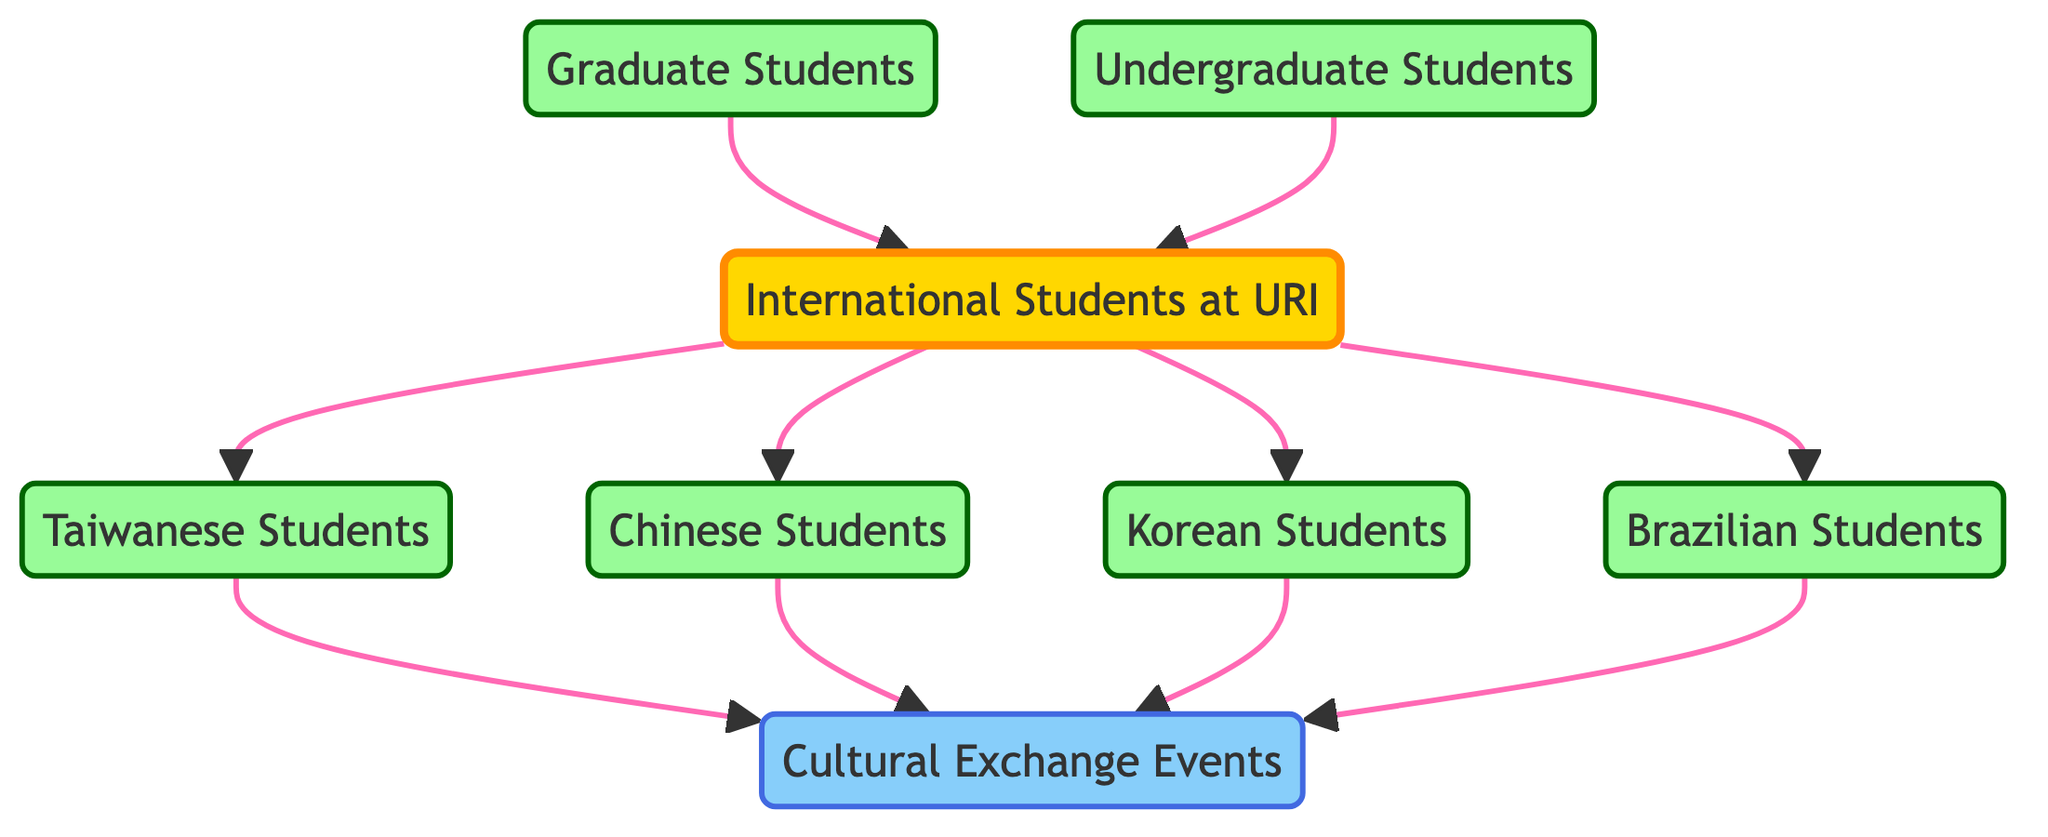What is the total number of nodes in the diagram? The diagram has eight distinct nodes that represent different groups: "International Students at URI," "Taiwanese Students," "Chinese Students," "Korean Students," "Brazilian Students," "Graduate Students," "Undergraduate Students," and "Cultural Exchange Events." Counting these gives a total of eight nodes.
Answer: 8 How many edges are there connecting the nodes? By examining the connections shown in the diagram, there are ten directed relationships (edges) between the nodes. This includes connections from "International Students" to the four student groups and additional connections from the student groups to "Cultural Exchange Events," along with edges from "Graduate Students" and "Undergraduate Students" to "International Students." Altogether, this totals to ten edges.
Answer: 10 Which group has connections to "Cultural Exchange Events"? The nodes "Taiwanese Students," "Chinese Students," "Korean Students," and "Brazilian Students" all have directed edges pointing towards "Cultural Exchange Events," indicating that these groups are connected to the events.
Answer: Taiwanese Students, Chinese Students, Korean Students, Brazilian Students What is the relationship between "International Students" and "Graduate Students"? The diagram indicates a directed edge from "Graduate Students" to "International Students," which means that "Graduate Students" share a connection to the overall category of "International Students." This shows that Graduate Students are part of the International Students network.
Answer: Directed edge How many student groups directly connect to "International Students"? The diagram illustrates that there are four distinct student groups that have direct connections to "International Students": "Taiwanese Students," "Chinese Students," "Korean Students," and "Brazilian Students." Counting these connections shows that there are four groups directly related to "International Students."
Answer: 4 What type of events are Taiwanese Students specifically connected to? In the diagram, "Taiwanese Students" have a directed edge towards "Cultural Exchange Events," indicating their involvement with this specific type of event. Thus, the Taiwanese Students are connected to cultural exchange events.
Answer: Cultural Exchange Events Which student category does not connect to "Cultural Exchange Events"? The diagram shows that "International Students" and the broader categories of "Graduate Students" and "Undergraduate Students" do not have any directed edges leading to "Cultural Exchange Events." Therefore, these categories do not connect to cultural exchange events, as they do not have direct associations toward that node.
Answer: International Students, Graduate Students, Undergraduate Students How many different countries are represented by the student groups in the diagram? The diagram explicitly identifies four distinct student groups categorized by their countries: Taiwan, China, Korea, and Brazil. This indicates that there are exactly four countries represented by the student groups in this social network.
Answer: 4 